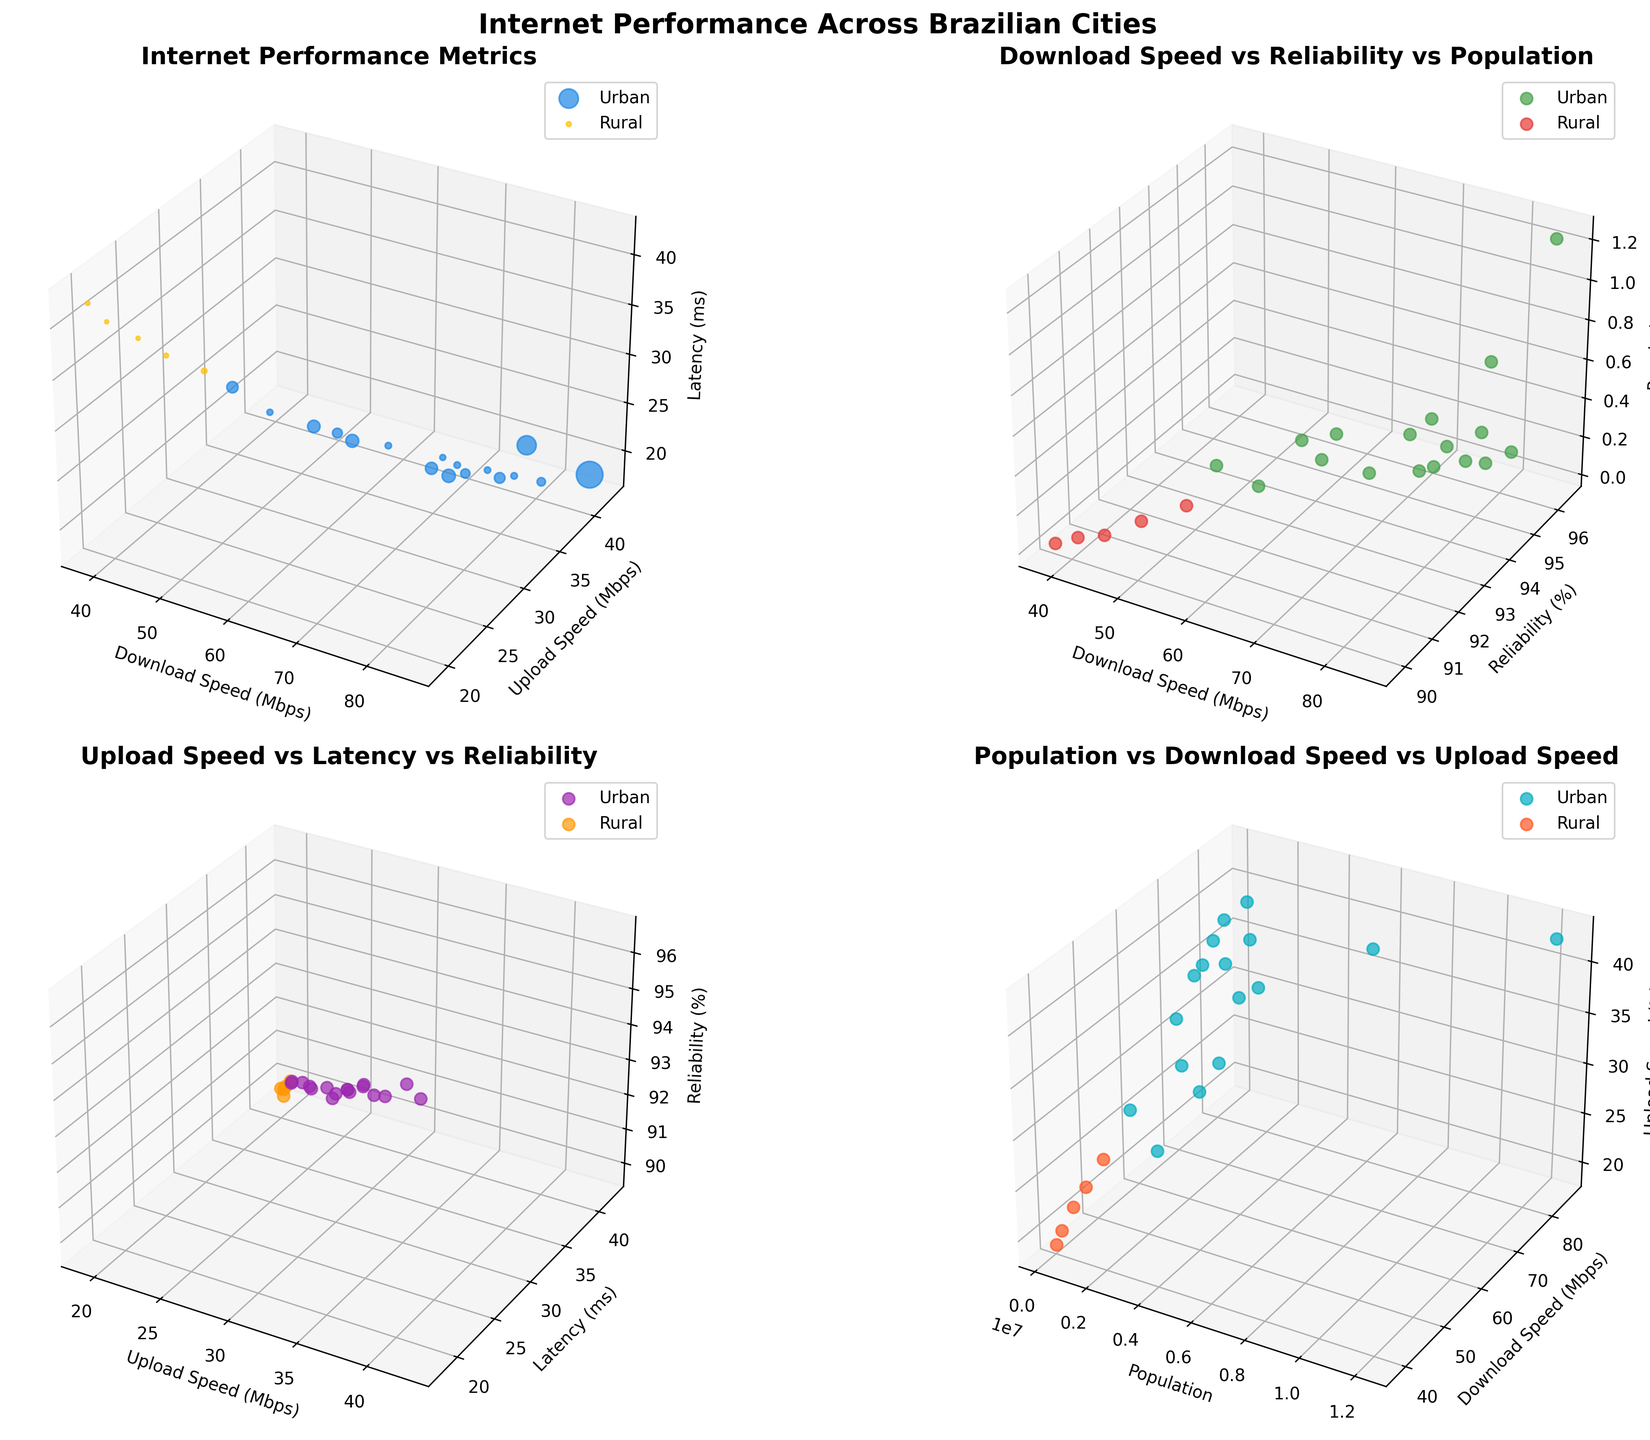What's the title of the figure? The title is located at the top of the figure, indicating the main subject of all the plots included. The title provides an overall summary of what the visual data represents.
Answer: Internet Performance Across Brazilian Cities How are urban and rural areas represented in Plot 1? Urban areas are represented in blue and rural areas are represented in orange. These colors help differentiate between the two types of areas at a glance.
Answer: Urban is blue, rural is orange Which city likely has the highest population in Plot 2? Larger marker sizes represent higher populations. In Plot 2, the largest marker would indicate the city with the highest population. Sao Paulo is seen with the largest marker.
Answer: Sao Paulo Which type of area generally has higher download speeds, urban or rural? By observing the spread and concentration of data points for urban and rural areas, it can be seen that urban areas generally have higher download speeds compared to rural areas.
Answer: Urban What is the relationship between reliability and download speed in urban areas according to Plot 2? Reviewing Plot 2, urban data points show that higher download speeds tend to correlate with higher reliability percentages. The general trend for urban areas indicates that as download speed increases, reliability also increases.
Answer: Positive correlation Which city appears to have the highest latency in urban areas according to Plot 3? By examining the z-axis (latency) and locating the highest point within the urban group, Fortaleza seems to have the highest latency in urban areas based on its position in Plot 3.
Answer: Fortaleza Which plot has the title "Population vs Download Speed vs Upload Speed"? By scanning the individual titles above each subplot, the last subplot (bottom-right corner) holds this title. It relates population size to download and upload speeds.
Answer: Plot 4 Between which two variables does the most consistent linear relationship appear in the plots? Observing the data distributions and patterns, Plot 2 shows the most consistent linear relationship between download speed and reliability, especially in urban areas. The trend seems more direct and uniform.
Answer: Download speed and reliability In which plot do urban areas show a wider spread of data points along the z-axis (Latency)? Urban areas demonstrate a wider spread in latency values (z-axis) most evidently in Plot 3, indicating varying latency within urban areas compared to more concentrated values in rural areas.
Answer: Plot 3 By looking at Plot 4, is there a visible trend indicating cities with higher populations tend to have faster upload speeds? In Plot 4, data points representing cities with higher populations also exhibit faster upload speeds, suggesting a general trend that higher population cities tend to have better upload speeds.
Answer: Yes 